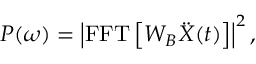Convert formula to latex. <formula><loc_0><loc_0><loc_500><loc_500>P ( \omega ) = \left | F F T \left [ W _ { B } \ddot { X } ( t ) \right ] \right | ^ { 2 } ,</formula> 